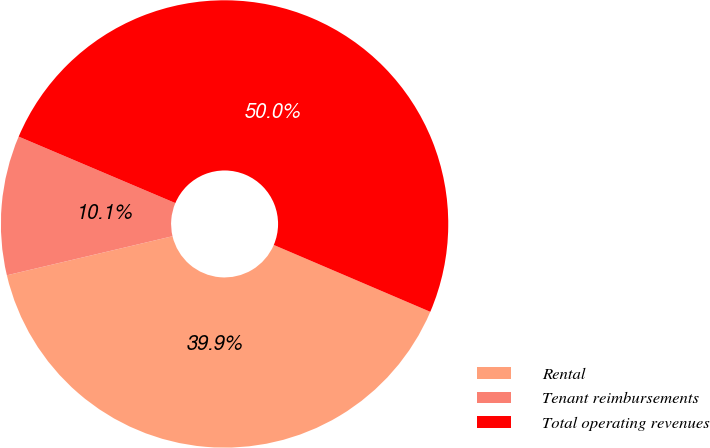<chart> <loc_0><loc_0><loc_500><loc_500><pie_chart><fcel>Rental<fcel>Tenant reimbursements<fcel>Total operating revenues<nl><fcel>39.89%<fcel>10.07%<fcel>50.04%<nl></chart> 